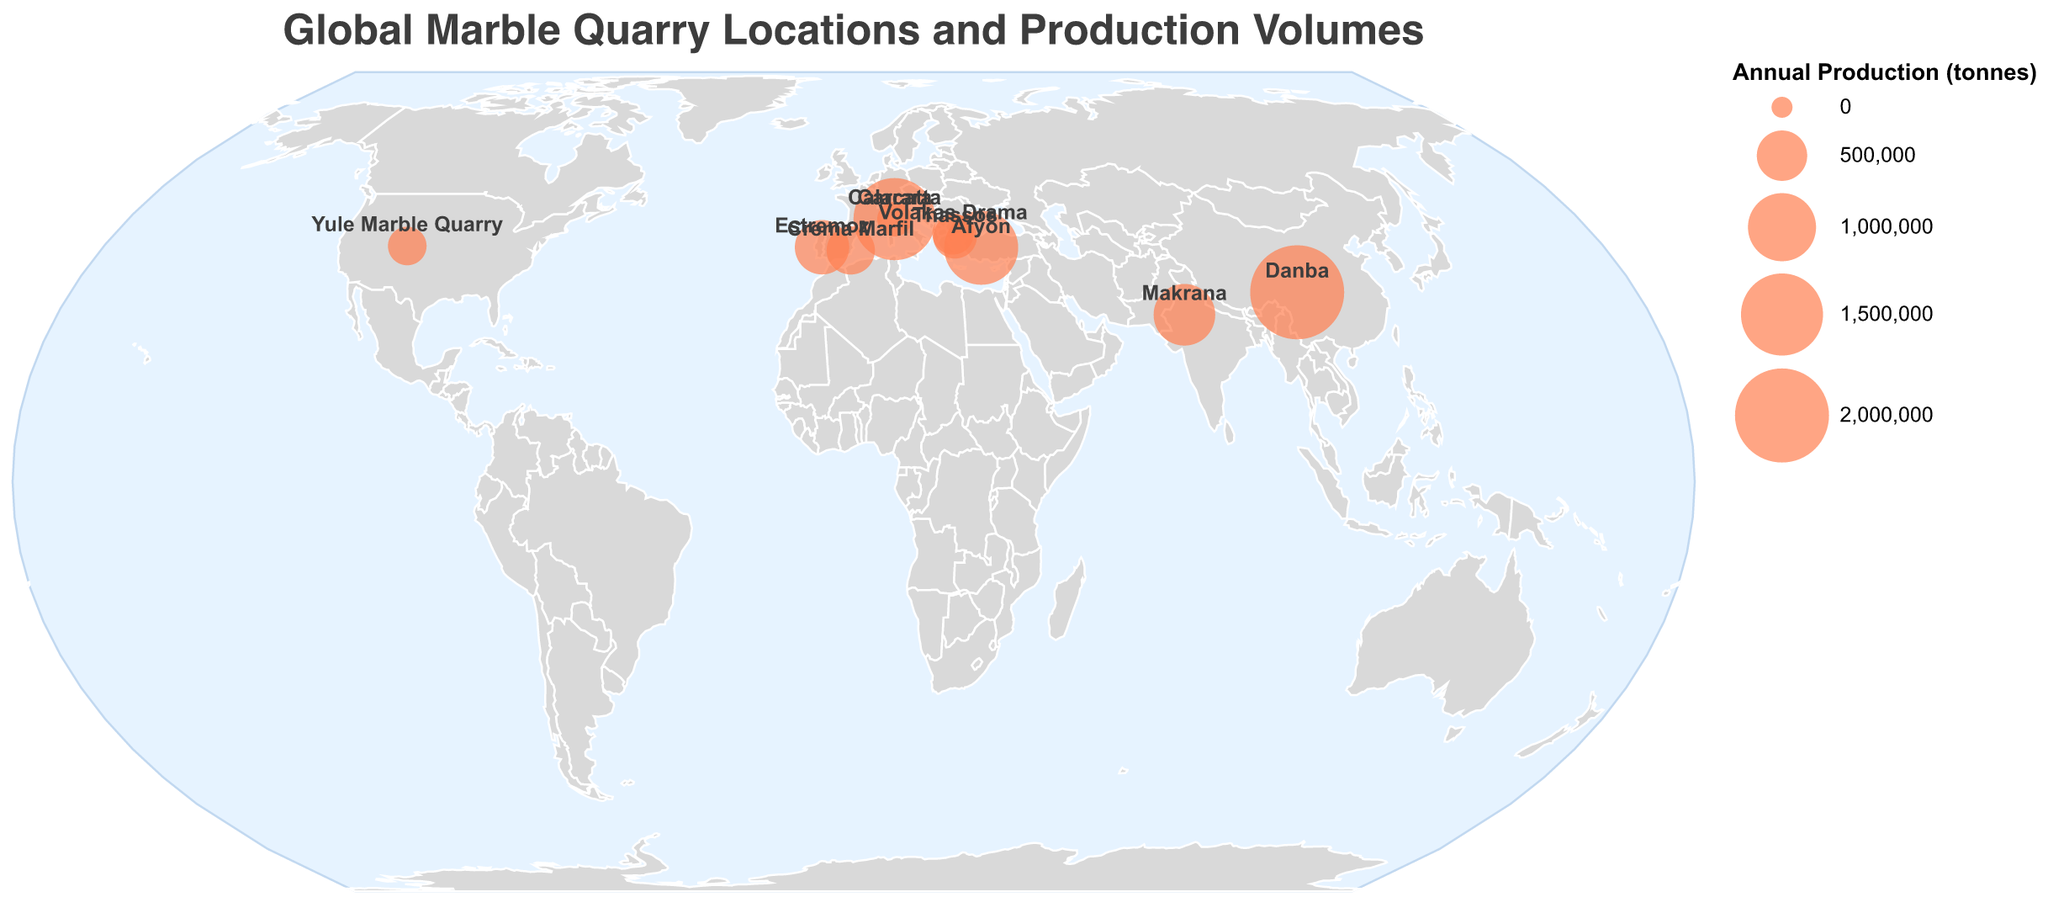What's the title of the figure? The title is displayed at the top center of the figure. It reads "Global Marble Quarry Locations and Production Volumes" in a large font.
Answer: Global Marble Quarry Locations and Production Volumes How many marble quarries are displayed on the map? Each quarry is represented by a labeled circle on the map. By counting them, we see there are 10 quarries displayed.
Answer: 10 Which quarry has the highest annual production of marble? The sizes of the circles represent production volumes, and the largest circle corresponds to the highest production. The tooltip indicates that Danba in China has the highest production with 2,000,000 tonnes per year.
Answer: Danba (China) What's the annual production of the Estremoz quarry in Portugal? By hovering over the circle for Estremoz, the tooltip reveals the annual production. The Estremoz quarry in Portugal produces 600,000 tonnes annually.
Answer: 600,000 tonnes How does the production of the Afyon quarry in Turkey compare to the Makrana quarry in India? To compare, we look at the sizes of the circles and the tooltips. Afyon's production is 1,200,000 tonnes, which is larger than Makrana's 800,000 tonnes.
Answer: Afyon produces more than Makrana Which country has multiple marble quarries mentioned in the chart? By looking at the labels and the data points on the map, we can see that Italy has two quarries: Carrara and Calacatta.
Answer: Italy What is the combined annual production of Carrara and Calacatta in Italy? Adding the annual productions of Carrara (1,500,000 tonnes) and Calacatta (180,000 tonnes), we get a total of 1,680,000 tonnes.
Answer: 1,680,000 tonnes Which quarry is located furthest west on the map? By observing the longitude values, the quarry with the most western longitude (-107.1811) is Yule Marble Quarry in the USA.
Answer: Yule Marble Quarry (USA) What are the coordinates of the Thassos quarry in Greece? The figure shows labels with geographic coordinates next to each quarry. The coordinates of the Thassos quarry are 40.7800 (latitude) and 24.5957 (longitude).
Answer: 40.7800, 24.5957 How many quarries have an annual production less than 500,000 tonnes? By looking at the sizes of the circles and their tooltips, we count the quarries with production under 500,000 tonnes: Yule Marble Quarry (250,000 tonnes), Thassos (350,000 tonnes), Volakas Drama (300,000 tonnes), and Calacatta (180,000 tonnes). There are 4 such quarries.
Answer: 4 